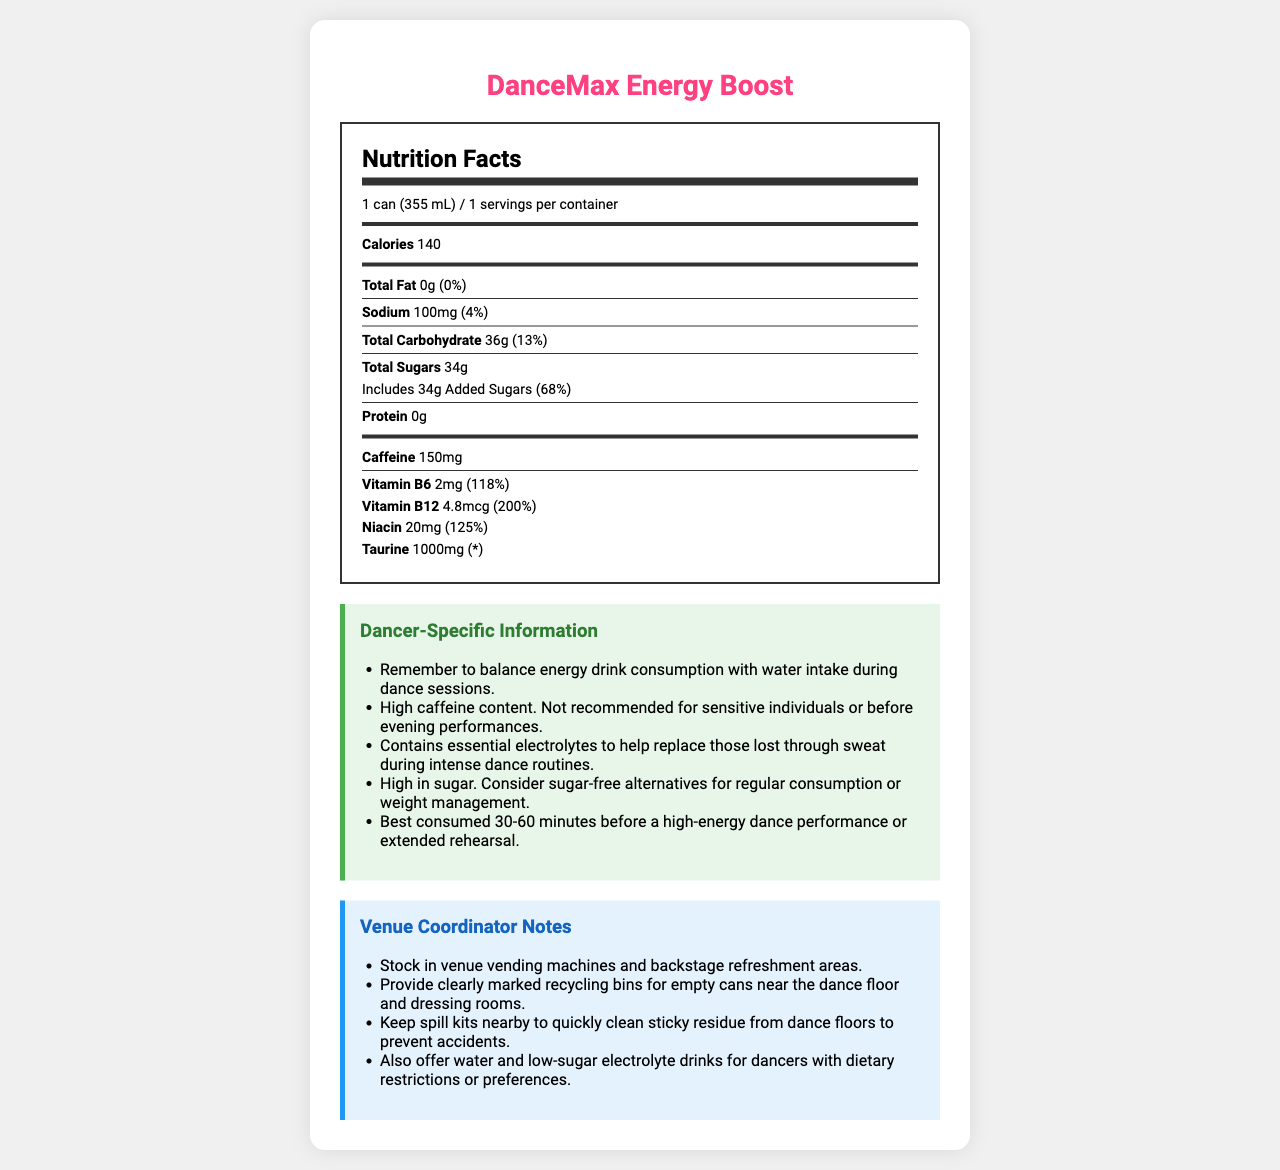what is the serving size for DanceMax Energy Boost? The serving size is listed as "1 can (355 mL)" at the beginning of the Nutrition Facts section.
Answer: 1 can (355 mL) how many calories are in one serving of DanceMax Energy Boost? The document states that there are 140 calories per serving.
Answer: 140 how much sodium does DanceMax Energy Boost contain? The sodium content is listed as "100mg" in the Nutrition Facts section.
Answer: 100mg what percent of the Daily Value is the sodium content? The sodium content contributes to 4% of the Daily Value for sodium.
Answer: 4% what are the total carbohydrates in DanceMax Energy Boost? The total carbohydrate content is listed as "36g" in the Nutrition Facts section.
Answer: 36g how much added sugar is in each can of DanceMax Energy Boost? The added sugars amount is listed as "34g" in the total sugars section.
Answer: 34g how much caffeine is in one can of DanceMax Energy Boost? The caffeine content is indicated as 150mg in the Nutrition Facts section.
Answer: 150mg how much Vitamin B12 does DanceMax Energy Boost provide? The document lists 4.8mcg of Vitamin B12 in the Nutrition Facts section.
Answer: 4.8mcg which vitamin or mineral is provided in the highest percent of Daily Value? A. Vitamin B6 B. Vitamin B12 C. Niacin D. Taurine Vitamin B12 has a Daily Value of 200%, which is the highest among the listed vitamins and minerals.
Answer: B. Vitamin B12 how many grams of protein are there in each serving? A. 10g B. 0g C. 20g D. 5g The protein content is listed as "0g" in the Nutrition Facts section.
Answer: B. 0g high caffeine content. Not recommended for sensitive individuals or before evening performances. This is stated under the Dancer-Specific Information section.
Answer: True how many servings are in one container of DanceMax Energy Boost? There is one serving per container as indicated in the document.
Answer: 1 What is the hydration reminder specific to dancers? The Dancer-Specific Information section includes this reminder about hydration.
Answer: Remember to balance energy drink consumption with water intake during dance sessions. What is the protein content of DanceMax Energy Boost? The Nutrition Facts section lists the protein content as 0g.
Answer: 0g Does DanceMax Energy Boost contain any fat? The document states that the total fat content is "0g (0%)", meaning it contains no fat.
Answer: No What are the primary ingredients in DanceMax Energy Boost? These ingredients are listed under the "other ingredients" section in the document.
Answer: Carbonated Water, Sucrose, Glucose, Citric Acid, Natural Flavors, Sodium Citrate, Potassium Phosphate, Caffeine, Guarana Seed Extract, Ginseng Root Extract, Caramel Color, Riboflavin What are the recommendations for venue coordinators regarding product availability? This recommendation is listed under the Venue Coordinator Notes section.
Answer: Stock in venue vending machines and backstage refreshment areas. How should empty cans of DanceMax Energy Boost be disposed of in a venue? This is stated under the disposal guidelines in the Venue Coordinator Notes section.
Answer: Provide clearly marked recycling bins for empty cans near the dance floor and dressing rooms. Summarize the key points of this document. This summary covers the primary sections and essential details provided in the document, giving an overview of both nutritional content and practical recommendations.
Answer: The document provides detailed nutritional information for DanceMax Energy Boost, including calorie count, macronutrient, caffeine, and vitamin content. It offers dancer-specific tips such as hydration reminders and caffeine warnings, and includes notes for venue coordinators on availability, disposal, spill protocols, and alternative options. What are the long-term health effects of consuming DanceMax Energy Boost regularly? The document does not provide information regarding the long-term health effects of regular consumption.
Answer: Not enough information 